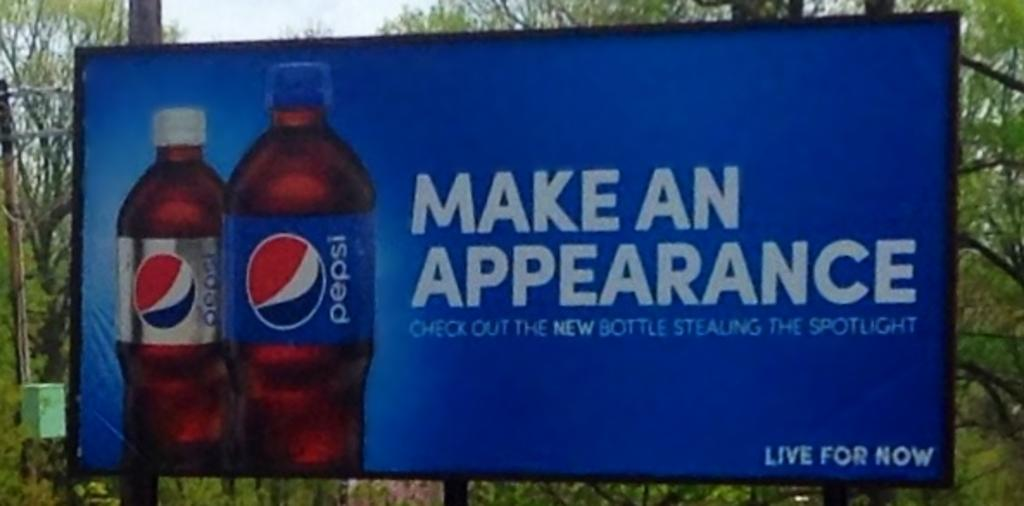<image>
Share a concise interpretation of the image provided. A billboard for Pepsi states "live for now" and to "check out the new bottle stealing the spotlight" 